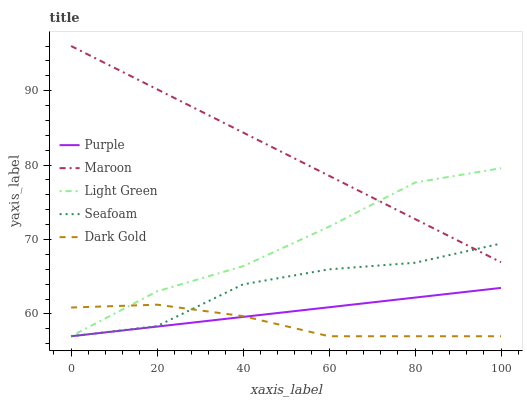Does Dark Gold have the minimum area under the curve?
Answer yes or no. Yes. Does Maroon have the maximum area under the curve?
Answer yes or no. Yes. Does Light Green have the minimum area under the curve?
Answer yes or no. No. Does Light Green have the maximum area under the curve?
Answer yes or no. No. Is Purple the smoothest?
Answer yes or no. Yes. Is Seafoam the roughest?
Answer yes or no. Yes. Is Dark Gold the smoothest?
Answer yes or no. No. Is Dark Gold the roughest?
Answer yes or no. No. Does Purple have the lowest value?
Answer yes or no. Yes. Does Maroon have the lowest value?
Answer yes or no. No. Does Maroon have the highest value?
Answer yes or no. Yes. Does Light Green have the highest value?
Answer yes or no. No. Is Purple less than Maroon?
Answer yes or no. Yes. Is Maroon greater than Dark Gold?
Answer yes or no. Yes. Does Maroon intersect Light Green?
Answer yes or no. Yes. Is Maroon less than Light Green?
Answer yes or no. No. Is Maroon greater than Light Green?
Answer yes or no. No. Does Purple intersect Maroon?
Answer yes or no. No. 